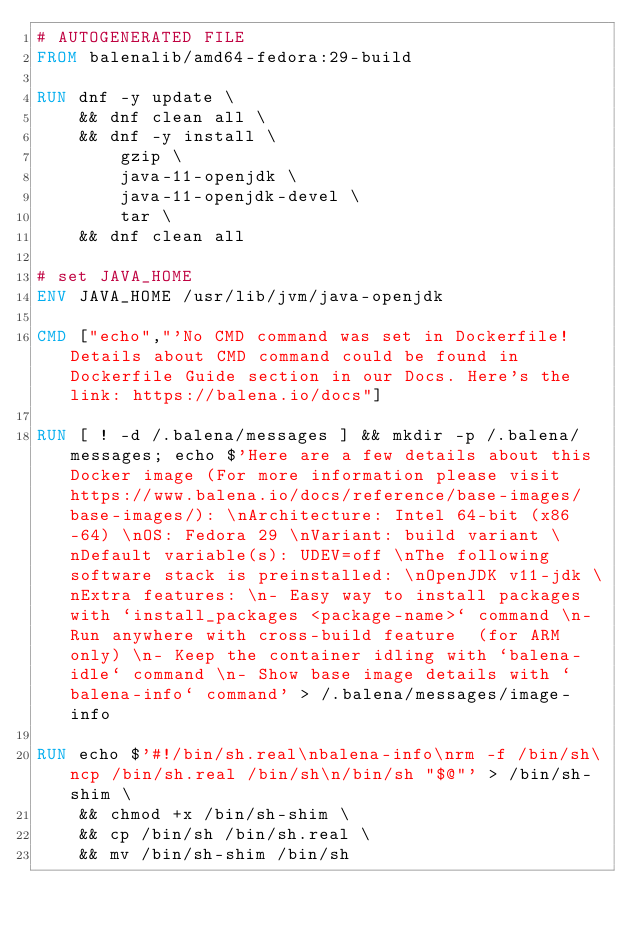<code> <loc_0><loc_0><loc_500><loc_500><_Dockerfile_># AUTOGENERATED FILE
FROM balenalib/amd64-fedora:29-build

RUN dnf -y update \
	&& dnf clean all \
	&& dnf -y install \
		gzip \
		java-11-openjdk \
		java-11-openjdk-devel \
		tar \
	&& dnf clean all

# set JAVA_HOME
ENV JAVA_HOME /usr/lib/jvm/java-openjdk

CMD ["echo","'No CMD command was set in Dockerfile! Details about CMD command could be found in Dockerfile Guide section in our Docs. Here's the link: https://balena.io/docs"]

RUN [ ! -d /.balena/messages ] && mkdir -p /.balena/messages; echo $'Here are a few details about this Docker image (For more information please visit https://www.balena.io/docs/reference/base-images/base-images/): \nArchitecture: Intel 64-bit (x86-64) \nOS: Fedora 29 \nVariant: build variant \nDefault variable(s): UDEV=off \nThe following software stack is preinstalled: \nOpenJDK v11-jdk \nExtra features: \n- Easy way to install packages with `install_packages <package-name>` command \n- Run anywhere with cross-build feature  (for ARM only) \n- Keep the container idling with `balena-idle` command \n- Show base image details with `balena-info` command' > /.balena/messages/image-info

RUN echo $'#!/bin/sh.real\nbalena-info\nrm -f /bin/sh\ncp /bin/sh.real /bin/sh\n/bin/sh "$@"' > /bin/sh-shim \
	&& chmod +x /bin/sh-shim \
	&& cp /bin/sh /bin/sh.real \
	&& mv /bin/sh-shim /bin/sh</code> 